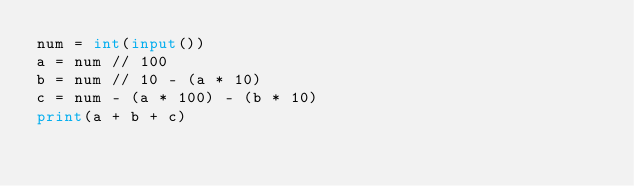<code> <loc_0><loc_0><loc_500><loc_500><_Python_>num = int(input())
a = num // 100
b = num // 10 - (a * 10)
c = num - (a * 100) - (b * 10)
print(a + b + c)</code> 